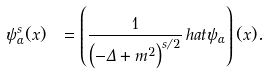<formula> <loc_0><loc_0><loc_500><loc_500>\psi _ { \alpha } ^ { s } ( x ) \ = \left ( { \frac { 1 } { \left ( - \Delta + m ^ { 2 } \right ) ^ { s / 2 } } } \, h a t { \psi } _ { \alpha } \right ) ( x ) .</formula> 